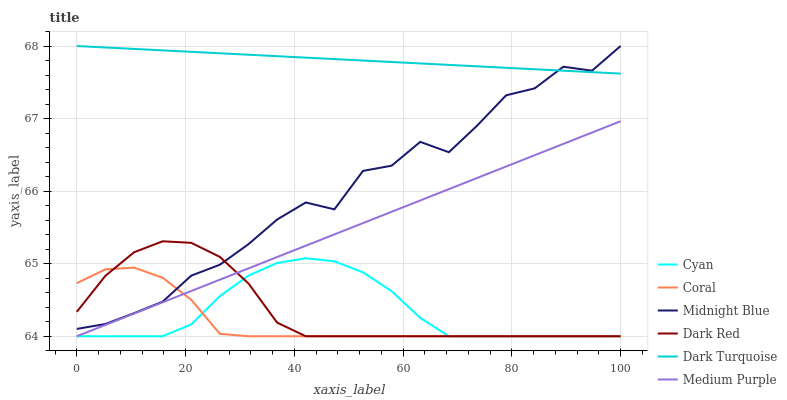Does Coral have the minimum area under the curve?
Answer yes or no. Yes. Does Dark Turquoise have the maximum area under the curve?
Answer yes or no. Yes. Does Dark Turquoise have the minimum area under the curve?
Answer yes or no. No. Does Coral have the maximum area under the curve?
Answer yes or no. No. Is Medium Purple the smoothest?
Answer yes or no. Yes. Is Midnight Blue the roughest?
Answer yes or no. Yes. Is Dark Turquoise the smoothest?
Answer yes or no. No. Is Dark Turquoise the roughest?
Answer yes or no. No. Does Coral have the lowest value?
Answer yes or no. Yes. Does Dark Turquoise have the lowest value?
Answer yes or no. No. Does Dark Turquoise have the highest value?
Answer yes or no. Yes. Does Coral have the highest value?
Answer yes or no. No. Is Cyan less than Midnight Blue?
Answer yes or no. Yes. Is Midnight Blue greater than Cyan?
Answer yes or no. Yes. Does Midnight Blue intersect Coral?
Answer yes or no. Yes. Is Midnight Blue less than Coral?
Answer yes or no. No. Is Midnight Blue greater than Coral?
Answer yes or no. No. Does Cyan intersect Midnight Blue?
Answer yes or no. No. 